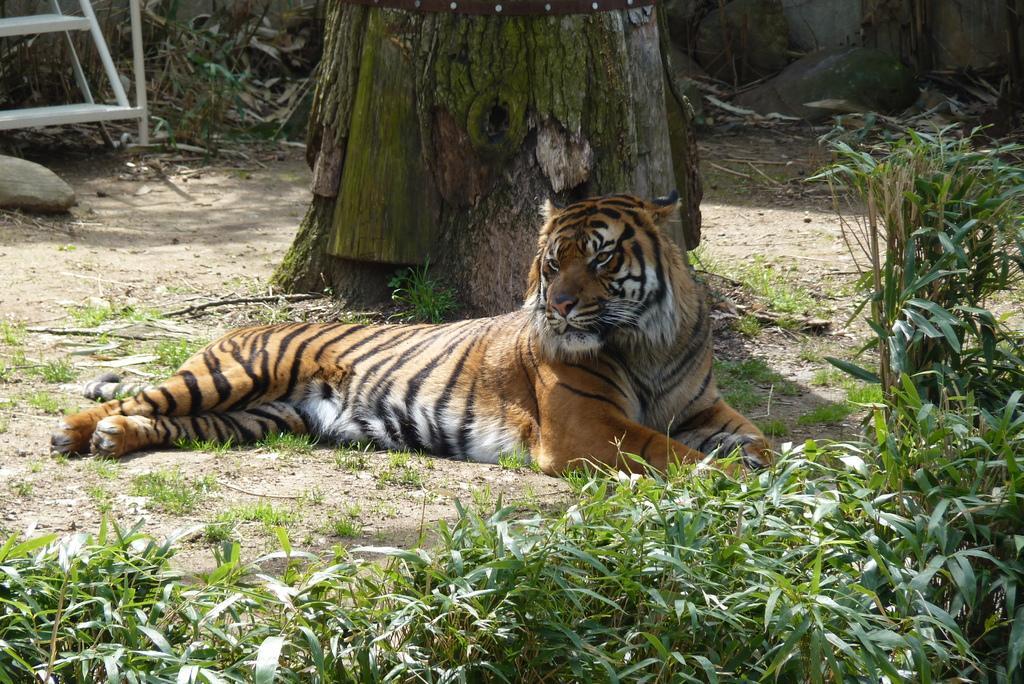Could you give a brief overview of what you see in this image? In this picture I can see a tiger laying on the ground, there are plants, there is tree trunk, it looks like a staircase. 